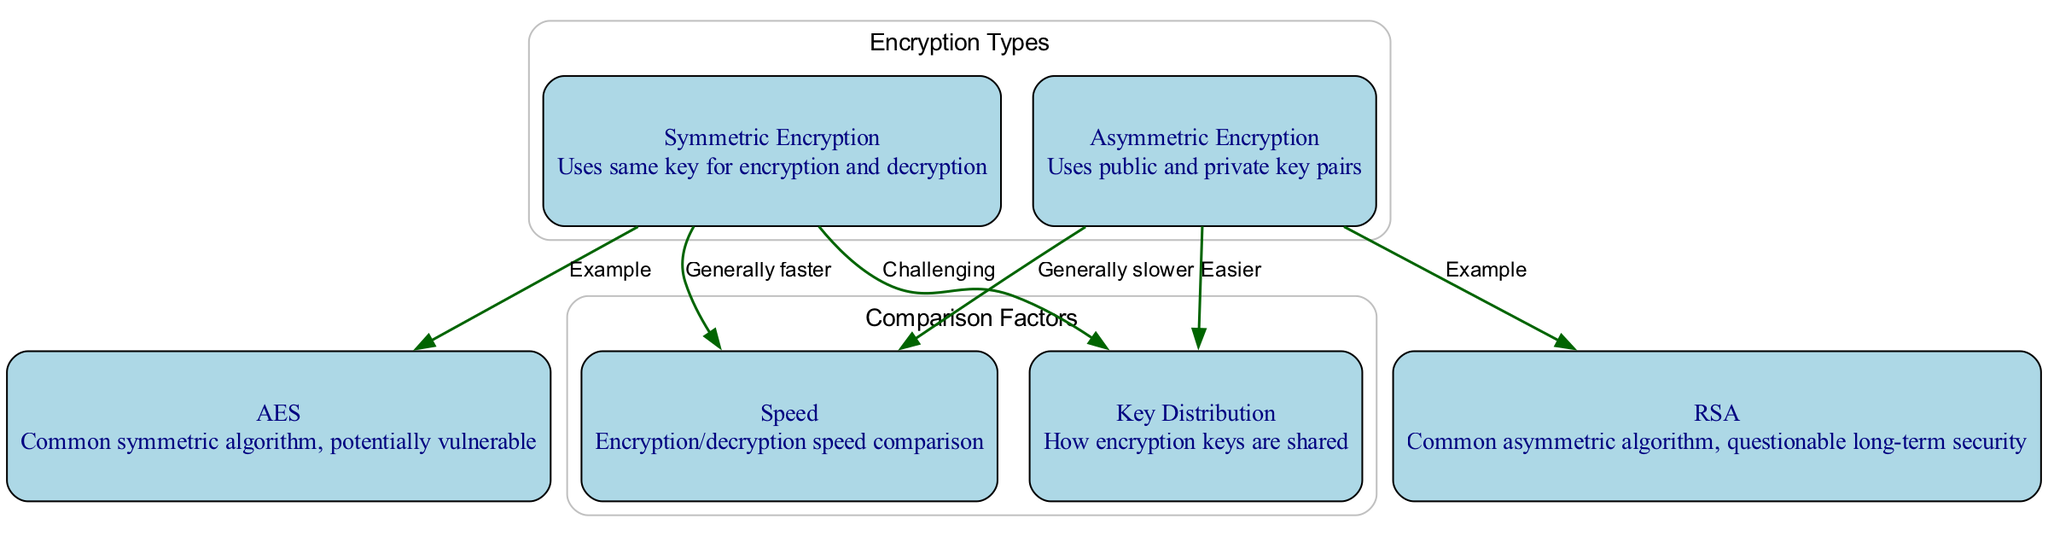What is the main difference between symmetric and asymmetric encryption? Symmetric encryption uses the same key for both encryption and decryption, whereas asymmetric encryption uses public and private key pairs. This is directly stated in the description of each encryption type in the diagram.
Answer: Uses same key for encryption and decryption vs. uses public and private key pairs What is an example of a symmetric encryption algorithm? The diagram specifically lists "AES" under symmetric encryption as an example, making it clear that it is a common algorithm used in this category.
Answer: AES Which encryption method is generally faster? The comparison shown in the diagram indicates a direct relationship, stating that symmetric encryption is generally faster than asymmetric encryption.
Answer: Symmetric How many total nodes are present in the diagram? By counting all the nodes listed in the diagram as well as considering the two encryption types (symmetric and asymmetric) and their associated factors (speed and key distribution), we find a total of six nodes.
Answer: 6 What type of key distribution is easier? According to the diagram, key distribution in asymmetric encryption is labeled as "easier," indicating that this method simplifies the process of sharing encryption keys when compared to symmetric encryption.
Answer: Easier What is a common vulnerability associated with AES? The diagram mentions AES as a common symmetric algorithm and states that it is "potentially vulnerable," pointing to concerns regarding its security.
Answer: Potentially vulnerable Which encryption method has a key distribution that is challenging? The diagram clearly marks symmetric encryption's key distribution as "challenging," indicating that this method faces difficulties in securely sharing keys.
Answer: Challenging What does RSA represent in the diagram? The diagram identifies RSA as a common asymmetric algorithm, and its description remarks on questionable long-term security, making its role explicit.
Answer: Common asymmetric algorithm Which encryption type shows a relation of being generally slower? The diagram connects the aspect of speed with asymmetric encryption, stating that it is generally slower than its symmetric counterpart, highlighting both methods' performance differences.
Answer: Generally slower 